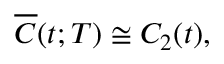<formula> <loc_0><loc_0><loc_500><loc_500>\begin{array} { r } { \overline { C } ( t ; T ) \cong C _ { 2 } ( t ) , } \end{array}</formula> 